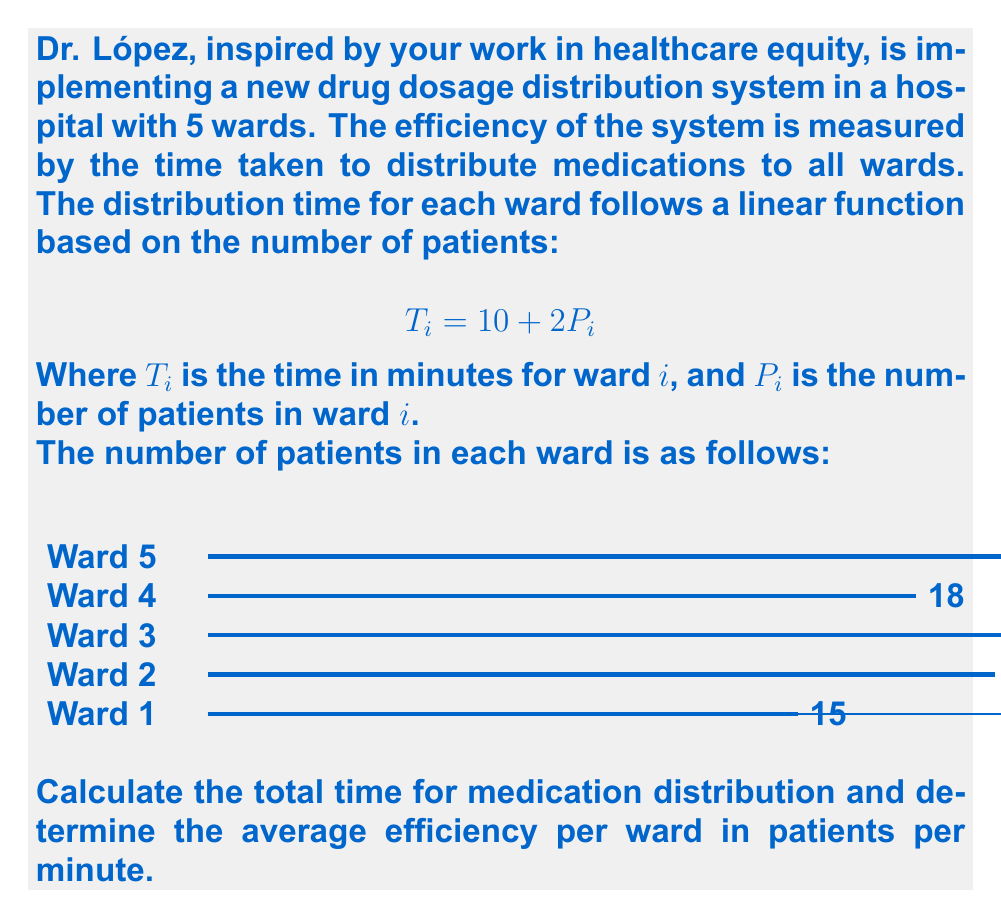What is the answer to this math problem? Let's approach this step-by-step:

1) First, calculate the time for each ward using the formula $T_i = 10 + 2P_i$:

   Ward 1: $T_1 = 10 + 2(15) = 40$ minutes
   Ward 2: $T_2 = 10 + 2(20) = 50$ minutes
   Ward 3: $T_3 = 10 + 2(25) = 60$ minutes
   Ward 4: $T_4 = 10 + 2(18) = 46$ minutes
   Ward 5: $T_5 = 10 + 2(22) = 54$ minutes

2) Calculate the total time by summing all ward times:

   $T_{total} = 40 + 50 + 60 + 46 + 54 = 250$ minutes

3) Calculate the total number of patients:

   $P_{total} = 15 + 20 + 25 + 18 + 22 = 100$ patients

4) Calculate the average efficiency per ward:

   Efficiency = $\frac{\text{Total patients}}{\text{Total time}} \times \text{Number of wards}$

   $E = \frac{100 \text{ patients}}{250 \text{ minutes}} \times 5 \text{ wards} = 2 \text{ patients/minute/ward}$
Answer: 250 minutes; 2 patients/minute/ward 